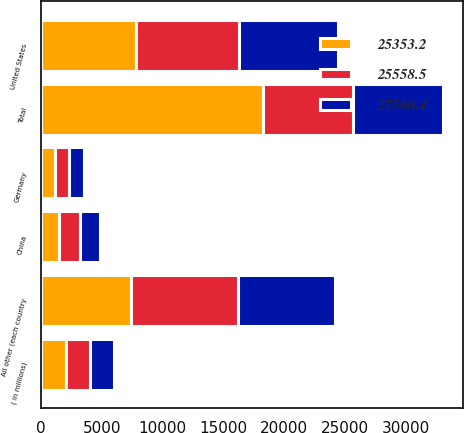Convert chart to OTSL. <chart><loc_0><loc_0><loc_500><loc_500><stacked_bar_chart><ecel><fcel>( in millions)<fcel>United States<fcel>China<fcel>Germany<fcel>All other (each country<fcel>Total<nl><fcel>25558.5<fcel>2014<fcel>8513.5<fcel>1740.4<fcel>1205.6<fcel>8797<fcel>7415.3<nl><fcel>27560.4<fcel>2013<fcel>8109.3<fcel>1631.8<fcel>1182.8<fcel>7945.1<fcel>7415.3<nl><fcel>25353.2<fcel>2012<fcel>7809.8<fcel>1443.5<fcel>1111.3<fcel>7415.3<fcel>18260.4<nl></chart> 